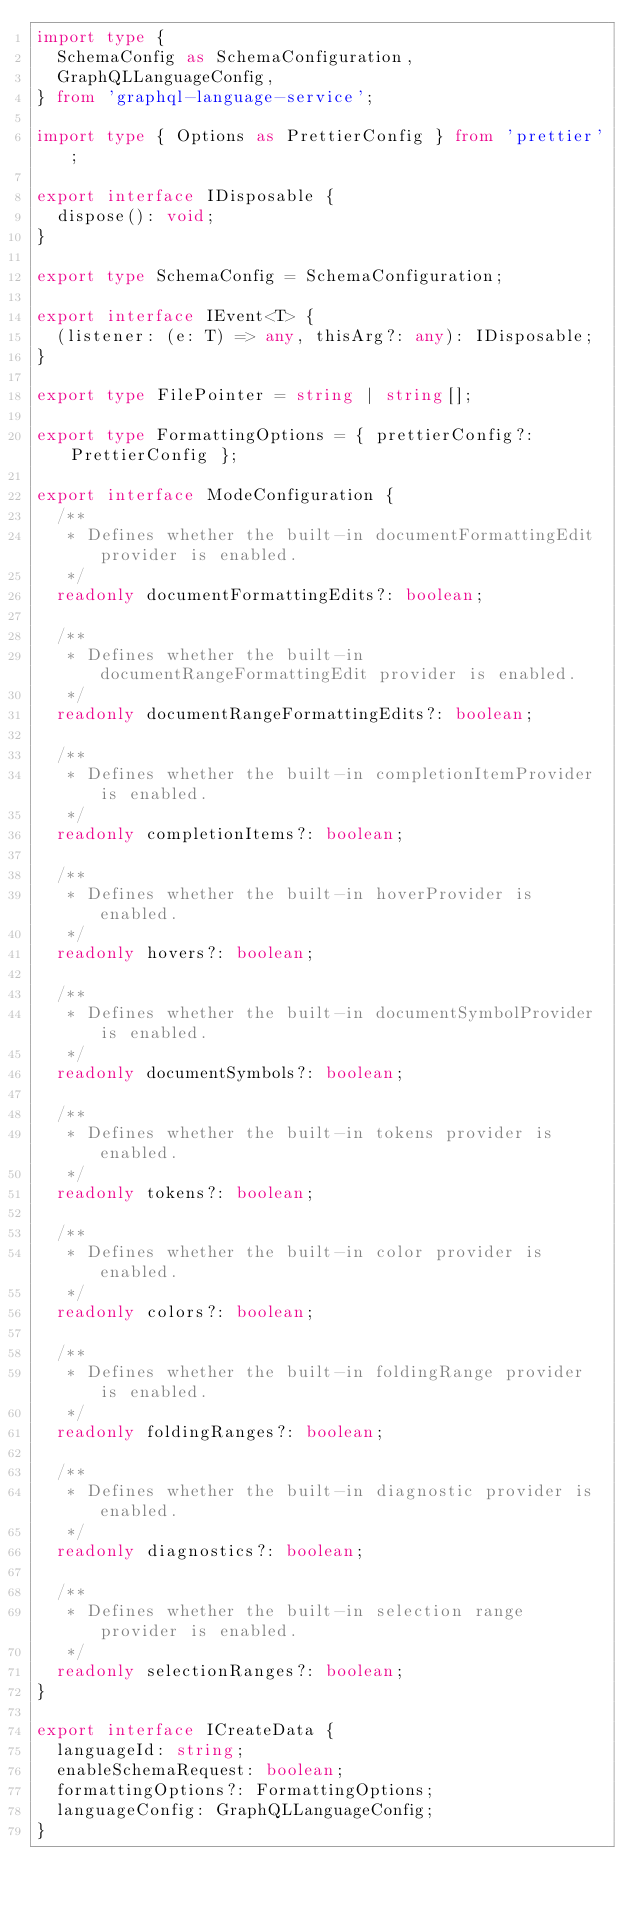<code> <loc_0><loc_0><loc_500><loc_500><_TypeScript_>import type {
  SchemaConfig as SchemaConfiguration,
  GraphQLLanguageConfig,
} from 'graphql-language-service';

import type { Options as PrettierConfig } from 'prettier';

export interface IDisposable {
  dispose(): void;
}

export type SchemaConfig = SchemaConfiguration;

export interface IEvent<T> {
  (listener: (e: T) => any, thisArg?: any): IDisposable;
}

export type FilePointer = string | string[];

export type FormattingOptions = { prettierConfig?: PrettierConfig };

export interface ModeConfiguration {
  /**
   * Defines whether the built-in documentFormattingEdit provider is enabled.
   */
  readonly documentFormattingEdits?: boolean;

  /**
   * Defines whether the built-in documentRangeFormattingEdit provider is enabled.
   */
  readonly documentRangeFormattingEdits?: boolean;

  /**
   * Defines whether the built-in completionItemProvider is enabled.
   */
  readonly completionItems?: boolean;

  /**
   * Defines whether the built-in hoverProvider is enabled.
   */
  readonly hovers?: boolean;

  /**
   * Defines whether the built-in documentSymbolProvider is enabled.
   */
  readonly documentSymbols?: boolean;

  /**
   * Defines whether the built-in tokens provider is enabled.
   */
  readonly tokens?: boolean;

  /**
   * Defines whether the built-in color provider is enabled.
   */
  readonly colors?: boolean;

  /**
   * Defines whether the built-in foldingRange provider is enabled.
   */
  readonly foldingRanges?: boolean;

  /**
   * Defines whether the built-in diagnostic provider is enabled.
   */
  readonly diagnostics?: boolean;

  /**
   * Defines whether the built-in selection range provider is enabled.
   */
  readonly selectionRanges?: boolean;
}

export interface ICreateData {
  languageId: string;
  enableSchemaRequest: boolean;
  formattingOptions?: FormattingOptions;
  languageConfig: GraphQLLanguageConfig;
}
</code> 